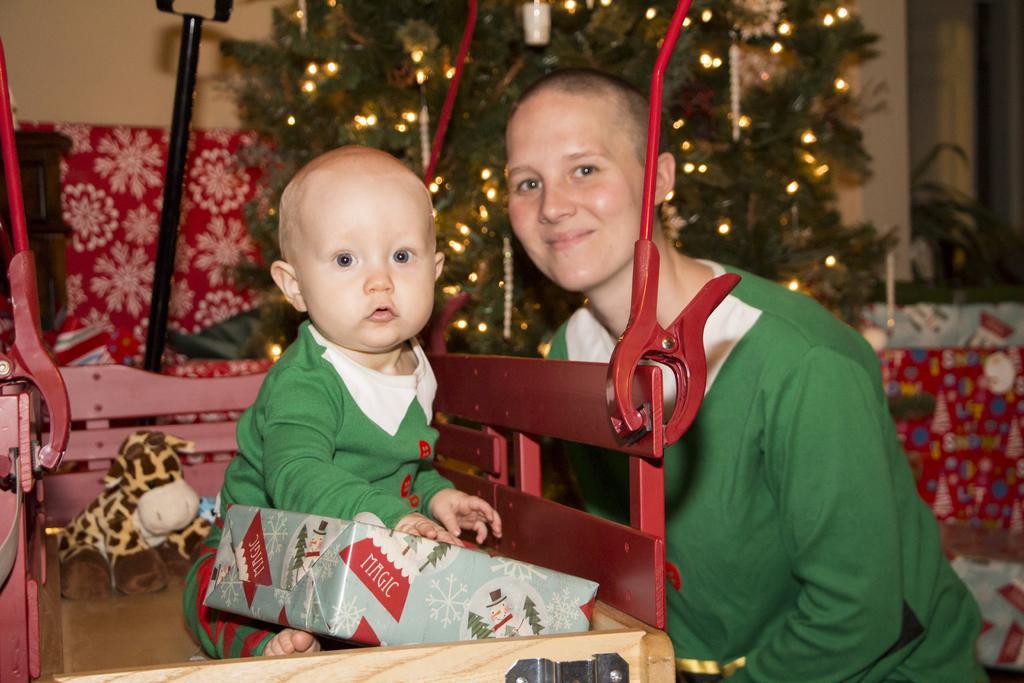Could you give a brief overview of what you see in this image? In this image we can see two persons. One baby is wearing green dress is holding a box in his hand. In the background, we can a tree, pole, a doll placed on the table. 